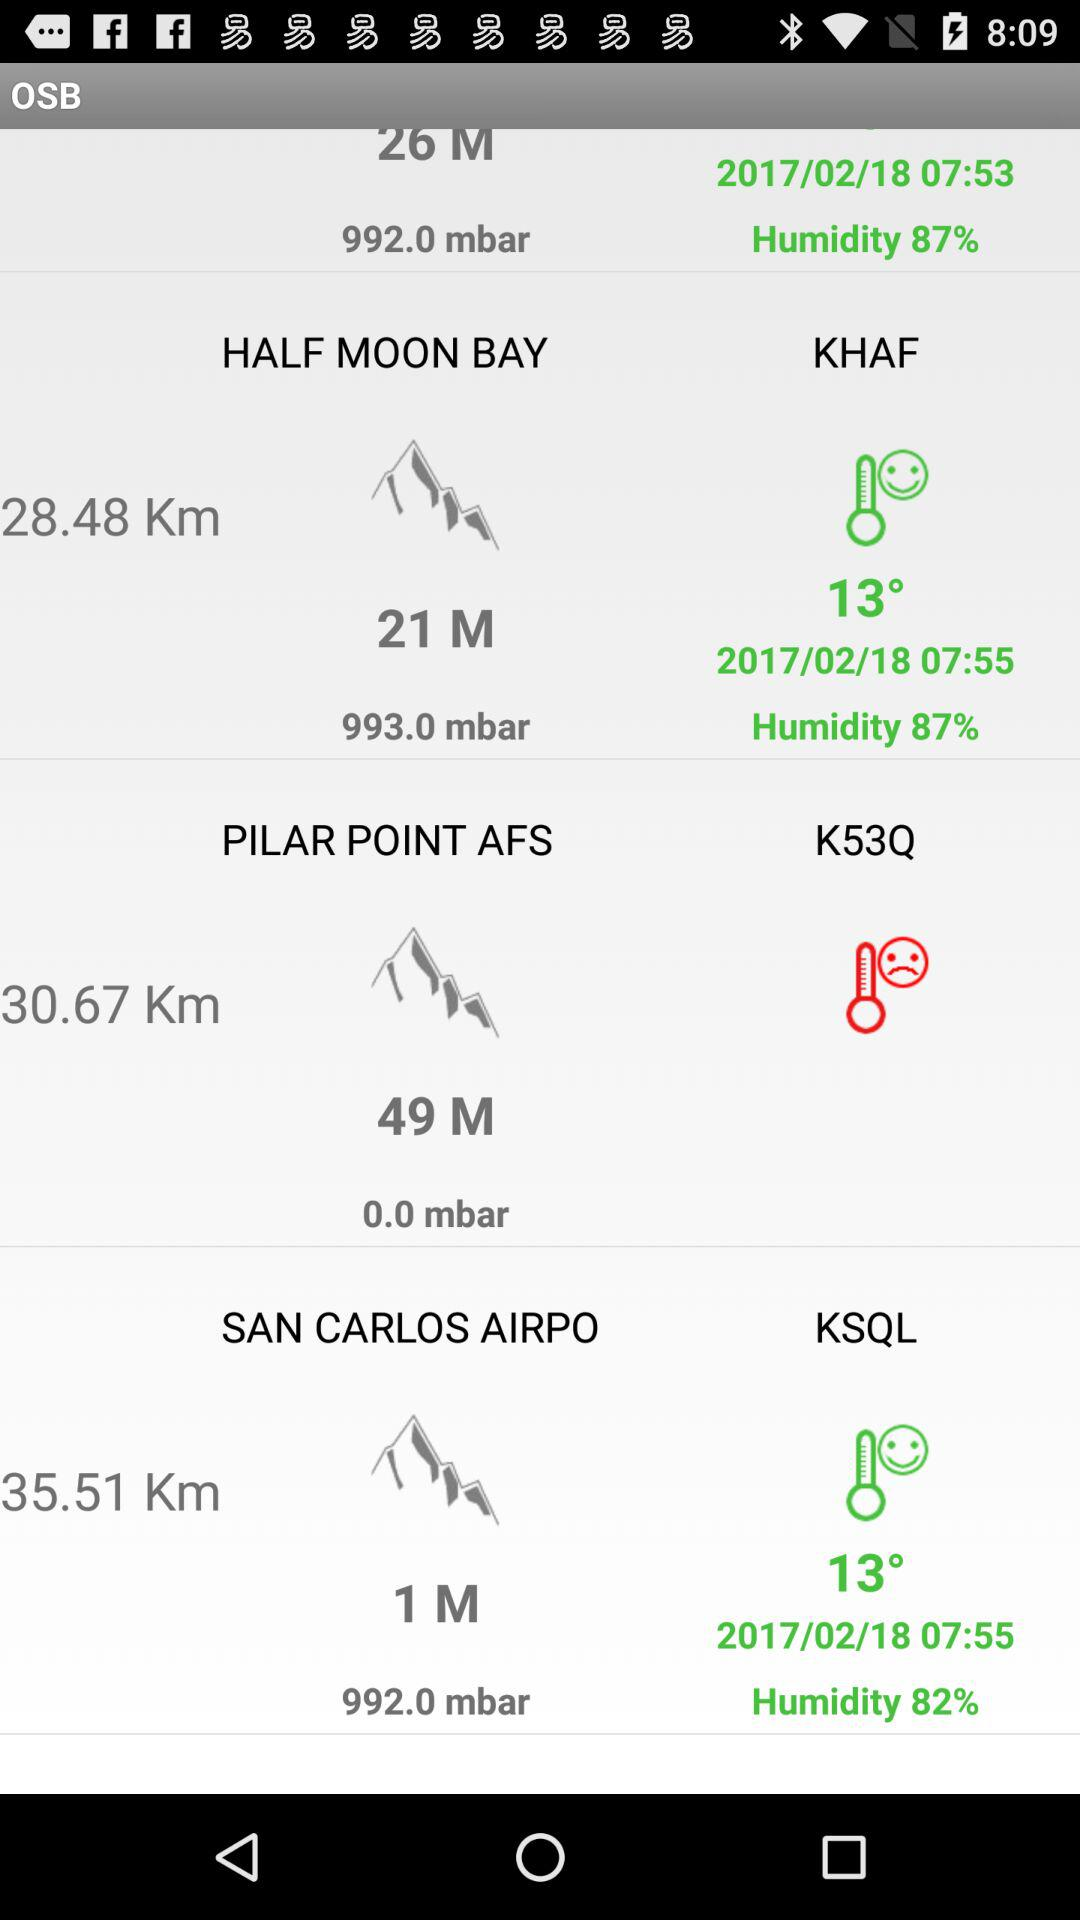What is the distance to Pilar Point AFS? The distance to Pilar Point AFS is 30.67 km. 